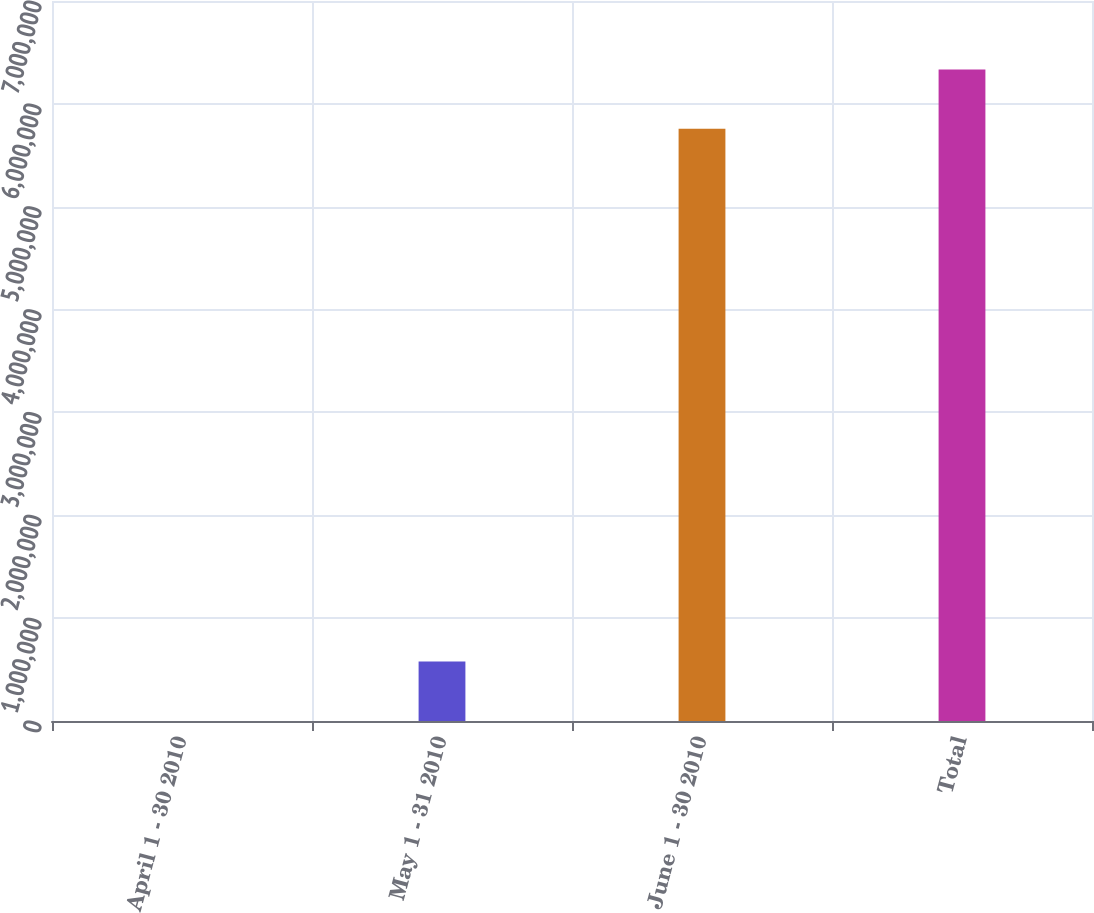Convert chart. <chart><loc_0><loc_0><loc_500><loc_500><bar_chart><fcel>April 1 - 30 2010<fcel>May 1 - 31 2010<fcel>June 1 - 30 2010<fcel>Total<nl><fcel>817<fcel>577295<fcel>5.7586e+06<fcel>6.33508e+06<nl></chart> 